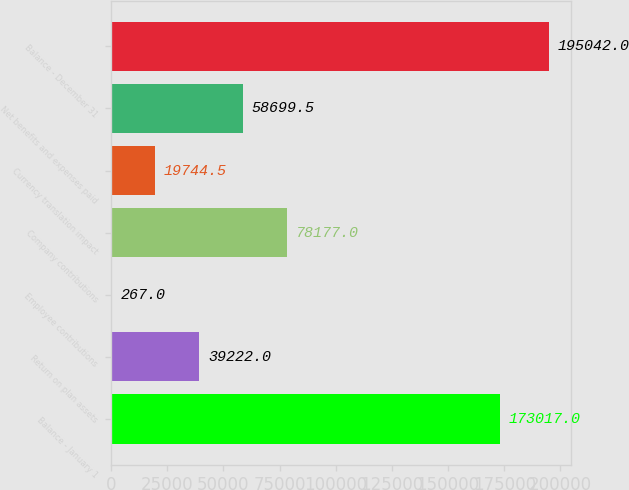Convert chart. <chart><loc_0><loc_0><loc_500><loc_500><bar_chart><fcel>Balance - January 1<fcel>Return on plan assets<fcel>Employee contributions<fcel>Company contributions<fcel>Currency translation impact<fcel>Net benefits and expenses paid<fcel>Balance - December 31<nl><fcel>173017<fcel>39222<fcel>267<fcel>78177<fcel>19744.5<fcel>58699.5<fcel>195042<nl></chart> 